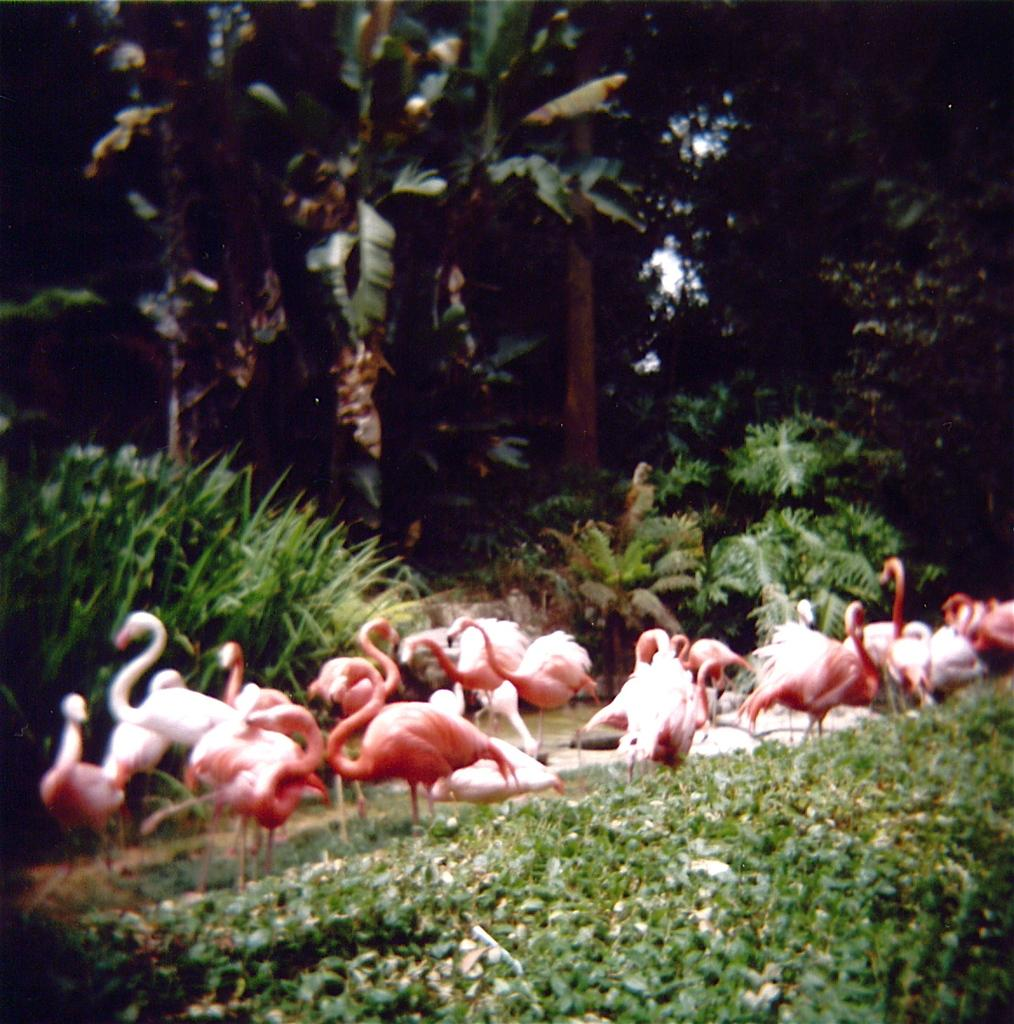What type of animals can be seen on the ground in the image? There are many ducks on the ground in the image. What type of vegetation is visible on the bottom of the image? There is grass visible on the bottom of the image. What can be seen in the background of the image? There are plants and many trees in the background of the image. What part of the natural environment is visible in the image? The sky is visible in the image. What type of appliance can be seen in the image? There is no appliance present in the image; it features ducks on the ground, grass, plants, trees, and the sky. 